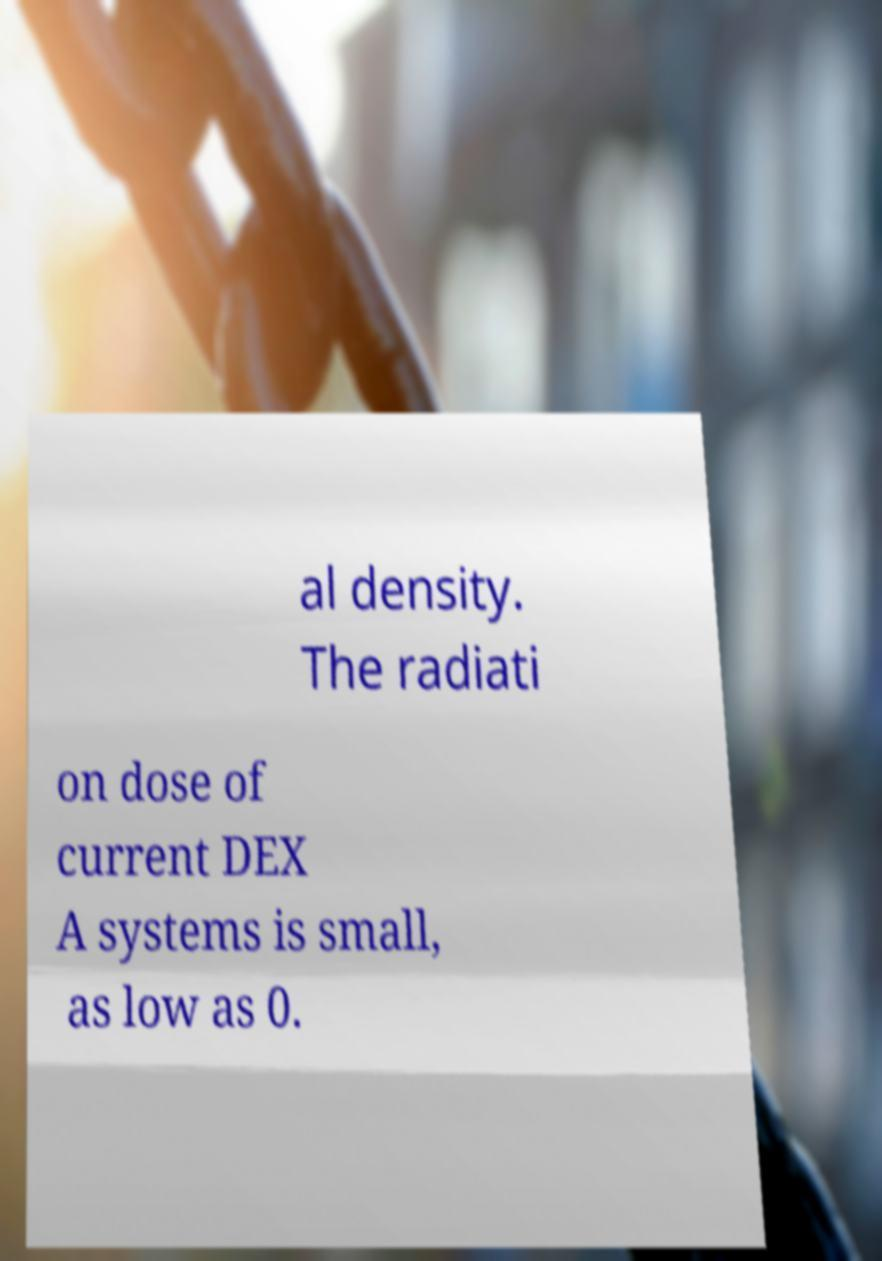For documentation purposes, I need the text within this image transcribed. Could you provide that? al density. The radiati on dose of current DEX A systems is small, as low as 0. 